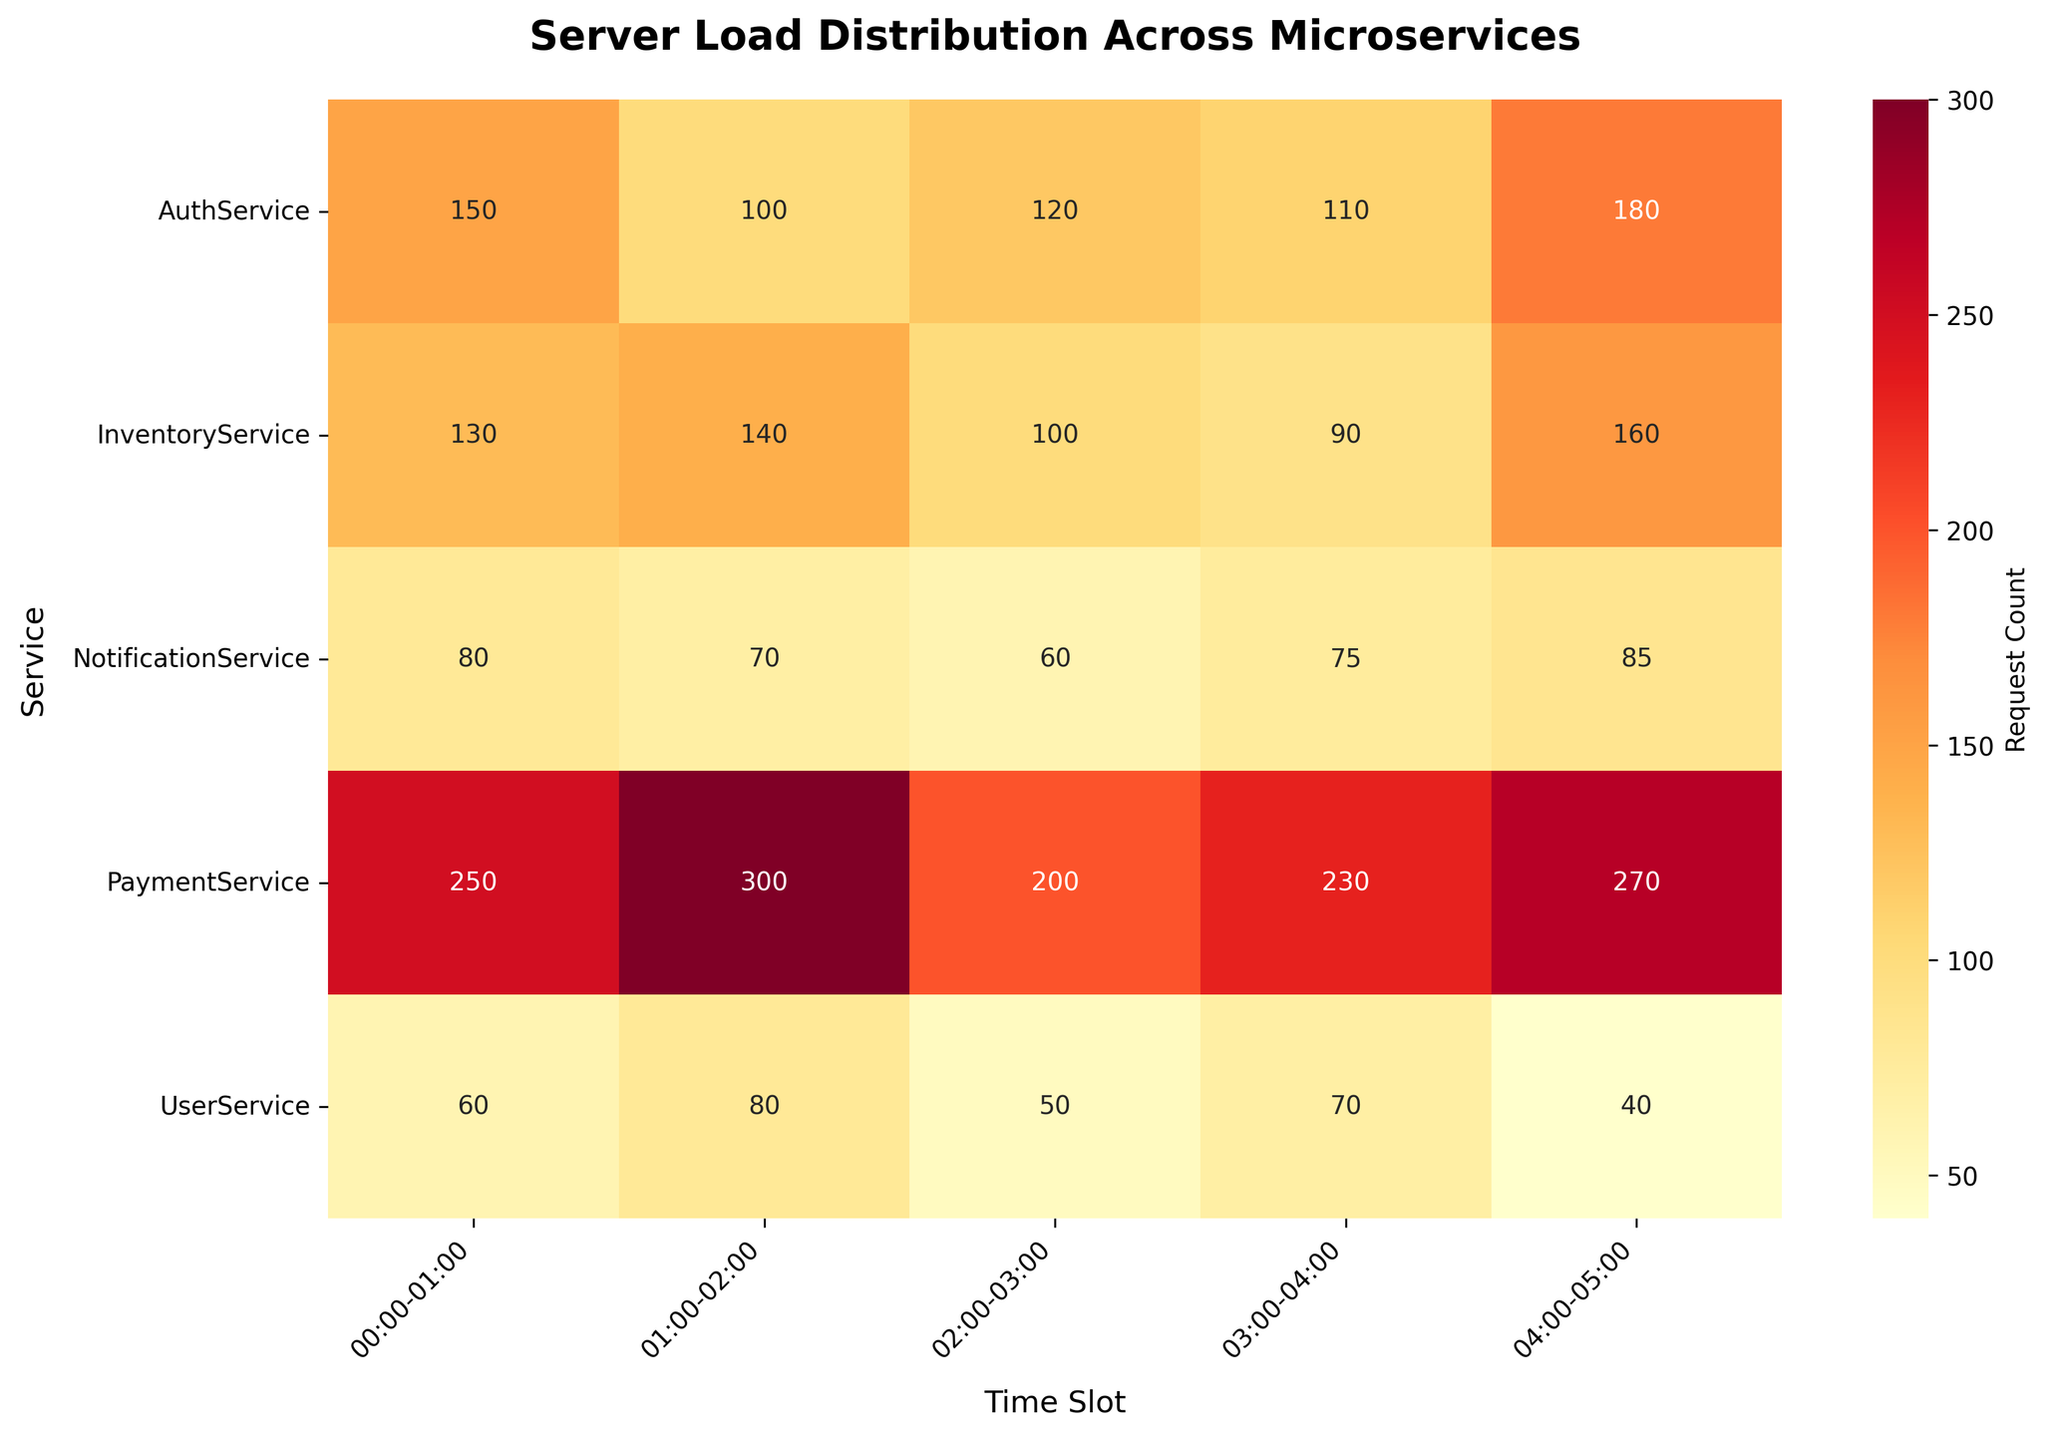What's the highest request count for the PaymentService? To find the highest request count for the PaymentService, locate the row corresponding to PaymentService and identify the highest value within that row. The values are 250, 300, 200, 230, and 270.
Answer: 300 Which time slot had the lowest request count for the AuthService? Identify the row for AuthService and find the smallest value among the listed request counts. The values are 150, 100, 120, 110, and 180.
Answer: 01:00-02:00 Which service had the least request load at 02:00-03:00? Locate the column for 02:00-03:00 and find the smallest value in that column. The values for 02:00-03:00 are 120 (AuthService), 50 (UserService), 200 (PaymentService), 100 (InventoryService), and 60 (NotificationService).
Answer: UserService What are the average request counts for InventoryService over the given time slots? Sum up the request counts for InventoryService and divide by the number of time slots. The values are 130, 140, 100, 90, and 160. The sum is 130 + 140 + 100 + 90 + 160 = 620, and there are 5 time slots, so 620/5 = 124.
Answer: 124 What is the total number of requests handled by NotificationService from 00:00 to 05:00? Add up all request counts for NotificationService over all time slots. The values are 80, 70, 60, 75, and 85. Therefore, the total request count is 80 + 70 + 60 + 75 + 85 = 370.
Answer: 370 Which service experienced the highest average load over the provided time slots? Calculate the average load for each service by summing their request counts and dividing by 5 (the number of time slots). The services and their total request counts are: AuthService (660), UserService (300), PaymentService (1250), InventoryService (620), and NotificationService (370).  The averages are: AuthService (660/5 = 132), UserService (300/5 = 60), PaymentService (1250/5 = 250), InventoryService (620/5 = 124), and NotificationService (370/5 = 74). The highest average load is 250.
Answer: PaymentService 